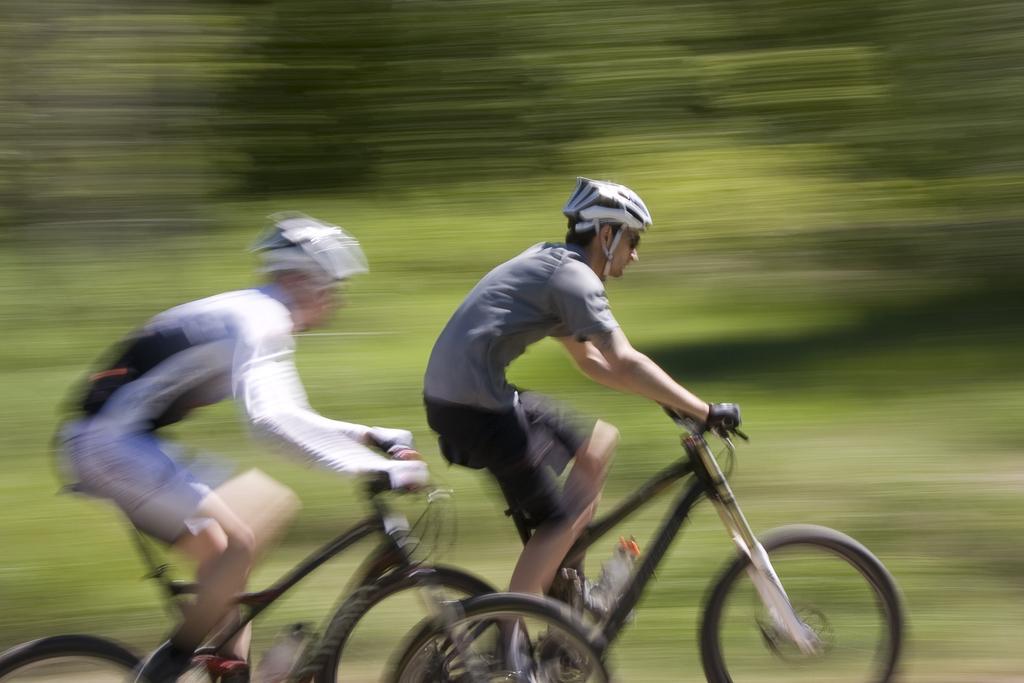Could you give a brief overview of what you see in this image? This image is clicked on the roads. There are two persons in this image. Both are riding bicycles. To the right, there is a man wearing gray color t-shirt and also wearing helmet. To the left, there is a man wearing white t-shirt and also wearing helmet. In the background there is grass and trees and also blurred. 